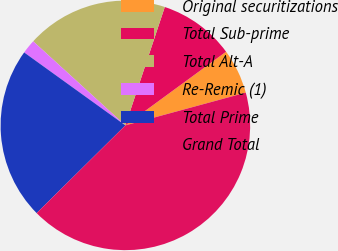Convert chart to OTSL. <chart><loc_0><loc_0><loc_500><loc_500><pie_chart><fcel>Original securitizations<fcel>Total Sub-prime<fcel>Total Alt-A<fcel>Re-Remic (1)<fcel>Total Prime<fcel>Grand Total<nl><fcel>5.83%<fcel>9.83%<fcel>18.35%<fcel>1.83%<fcel>22.35%<fcel>41.82%<nl></chart> 